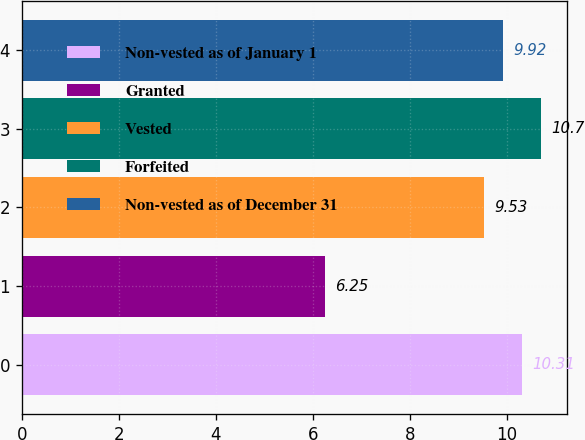Convert chart to OTSL. <chart><loc_0><loc_0><loc_500><loc_500><bar_chart><fcel>Non-vested as of January 1<fcel>Granted<fcel>Vested<fcel>Forfeited<fcel>Non-vested as of December 31<nl><fcel>10.31<fcel>6.25<fcel>9.53<fcel>10.7<fcel>9.92<nl></chart> 